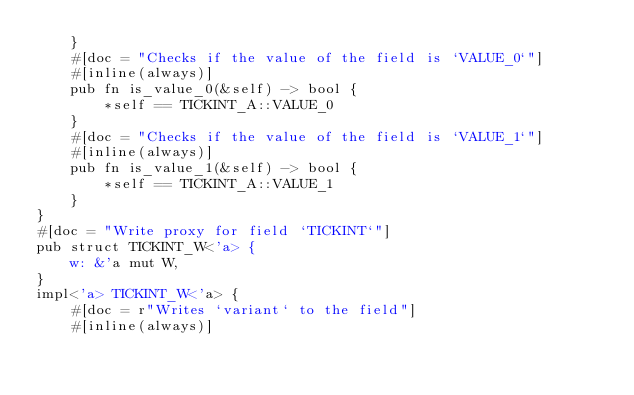<code> <loc_0><loc_0><loc_500><loc_500><_Rust_>    }
    #[doc = "Checks if the value of the field is `VALUE_0`"]
    #[inline(always)]
    pub fn is_value_0(&self) -> bool {
        *self == TICKINT_A::VALUE_0
    }
    #[doc = "Checks if the value of the field is `VALUE_1`"]
    #[inline(always)]
    pub fn is_value_1(&self) -> bool {
        *self == TICKINT_A::VALUE_1
    }
}
#[doc = "Write proxy for field `TICKINT`"]
pub struct TICKINT_W<'a> {
    w: &'a mut W,
}
impl<'a> TICKINT_W<'a> {
    #[doc = r"Writes `variant` to the field"]
    #[inline(always)]</code> 